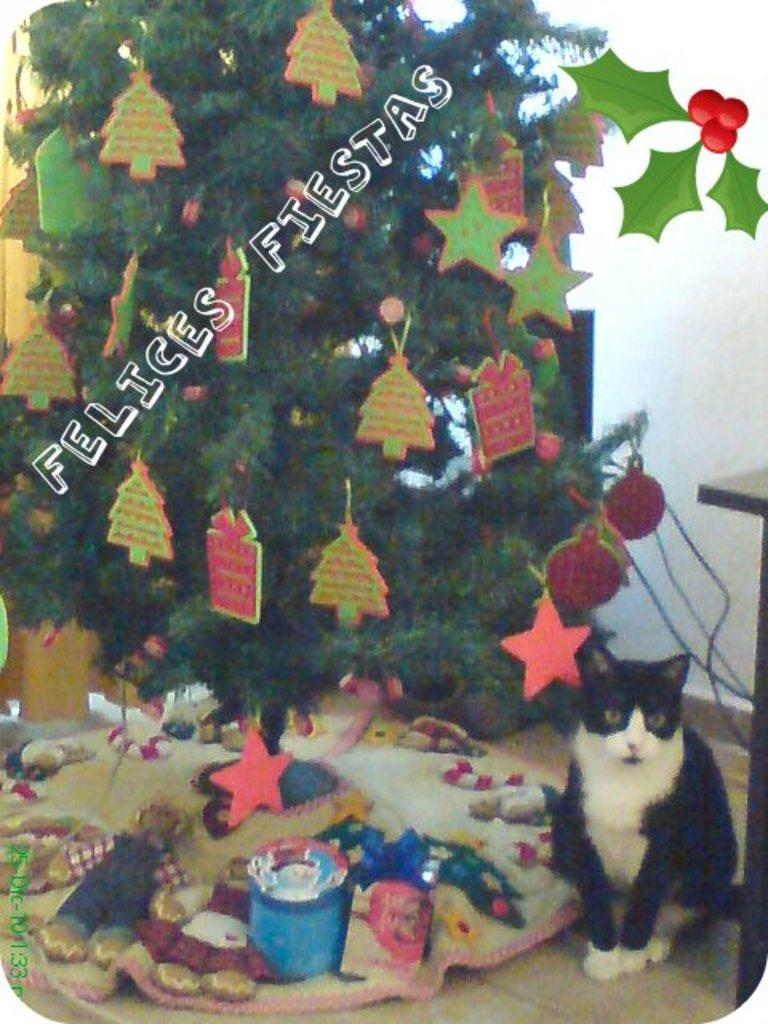Please provide a concise description of this image. In this image we can see the poster with a cat and Christmas tree. And we can see the cloth with dolls, boxes and a few objects. In the background, we can see the wall and text written on the poster. 